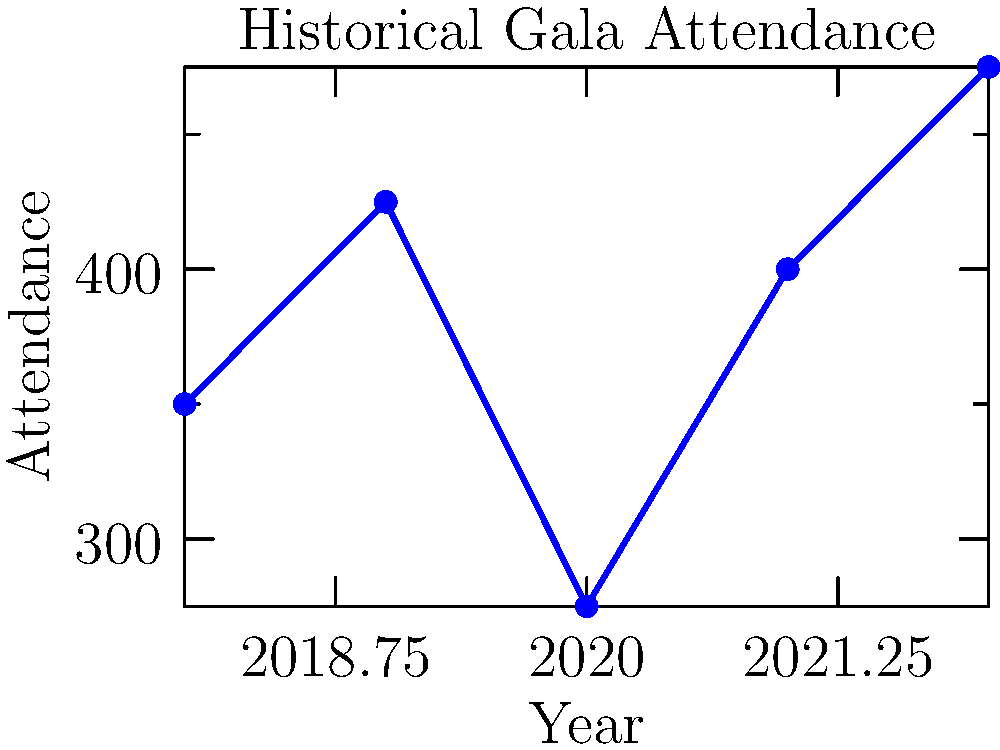Based on the historical gala attendance data shown in the line graph, what is the most likely attendance prediction for the upcoming 2023 gala event? To predict the attendance for the 2023 gala event, we need to analyze the trend in the given data:

1. Observe the attendance numbers from 2018 to 2022:
   2018: 350
   2019: 425
   2020: 275
   2021: 400
   2022: 475

2. Calculate the year-over-year changes:
   2018 to 2019: +75
   2019 to 2020: -150 (likely due to external factors, e.g., pandemic)
   2020 to 2021: +125
   2021 to 2022: +75

3. Identify the overall trend:
   - Excluding 2020 (an outlier year), there's a consistent upward trend.
   - The average increase (excluding 2020) is about 92 attendees per year.

4. Consider recent performance:
   - The last two years show strong recovery and growth.
   - The most recent increase (2021 to 2022) was 75 attendees.

5. Make a prediction:
   - Given the consistent growth and recent performance, it's reasonable to expect a similar increase for 2023.
   - Using the most recent increase as a conservative estimate: 475 + 75 = 550

Therefore, the most likely attendance prediction for the 2023 gala event is approximately 550 attendees.
Answer: 550 attendees 